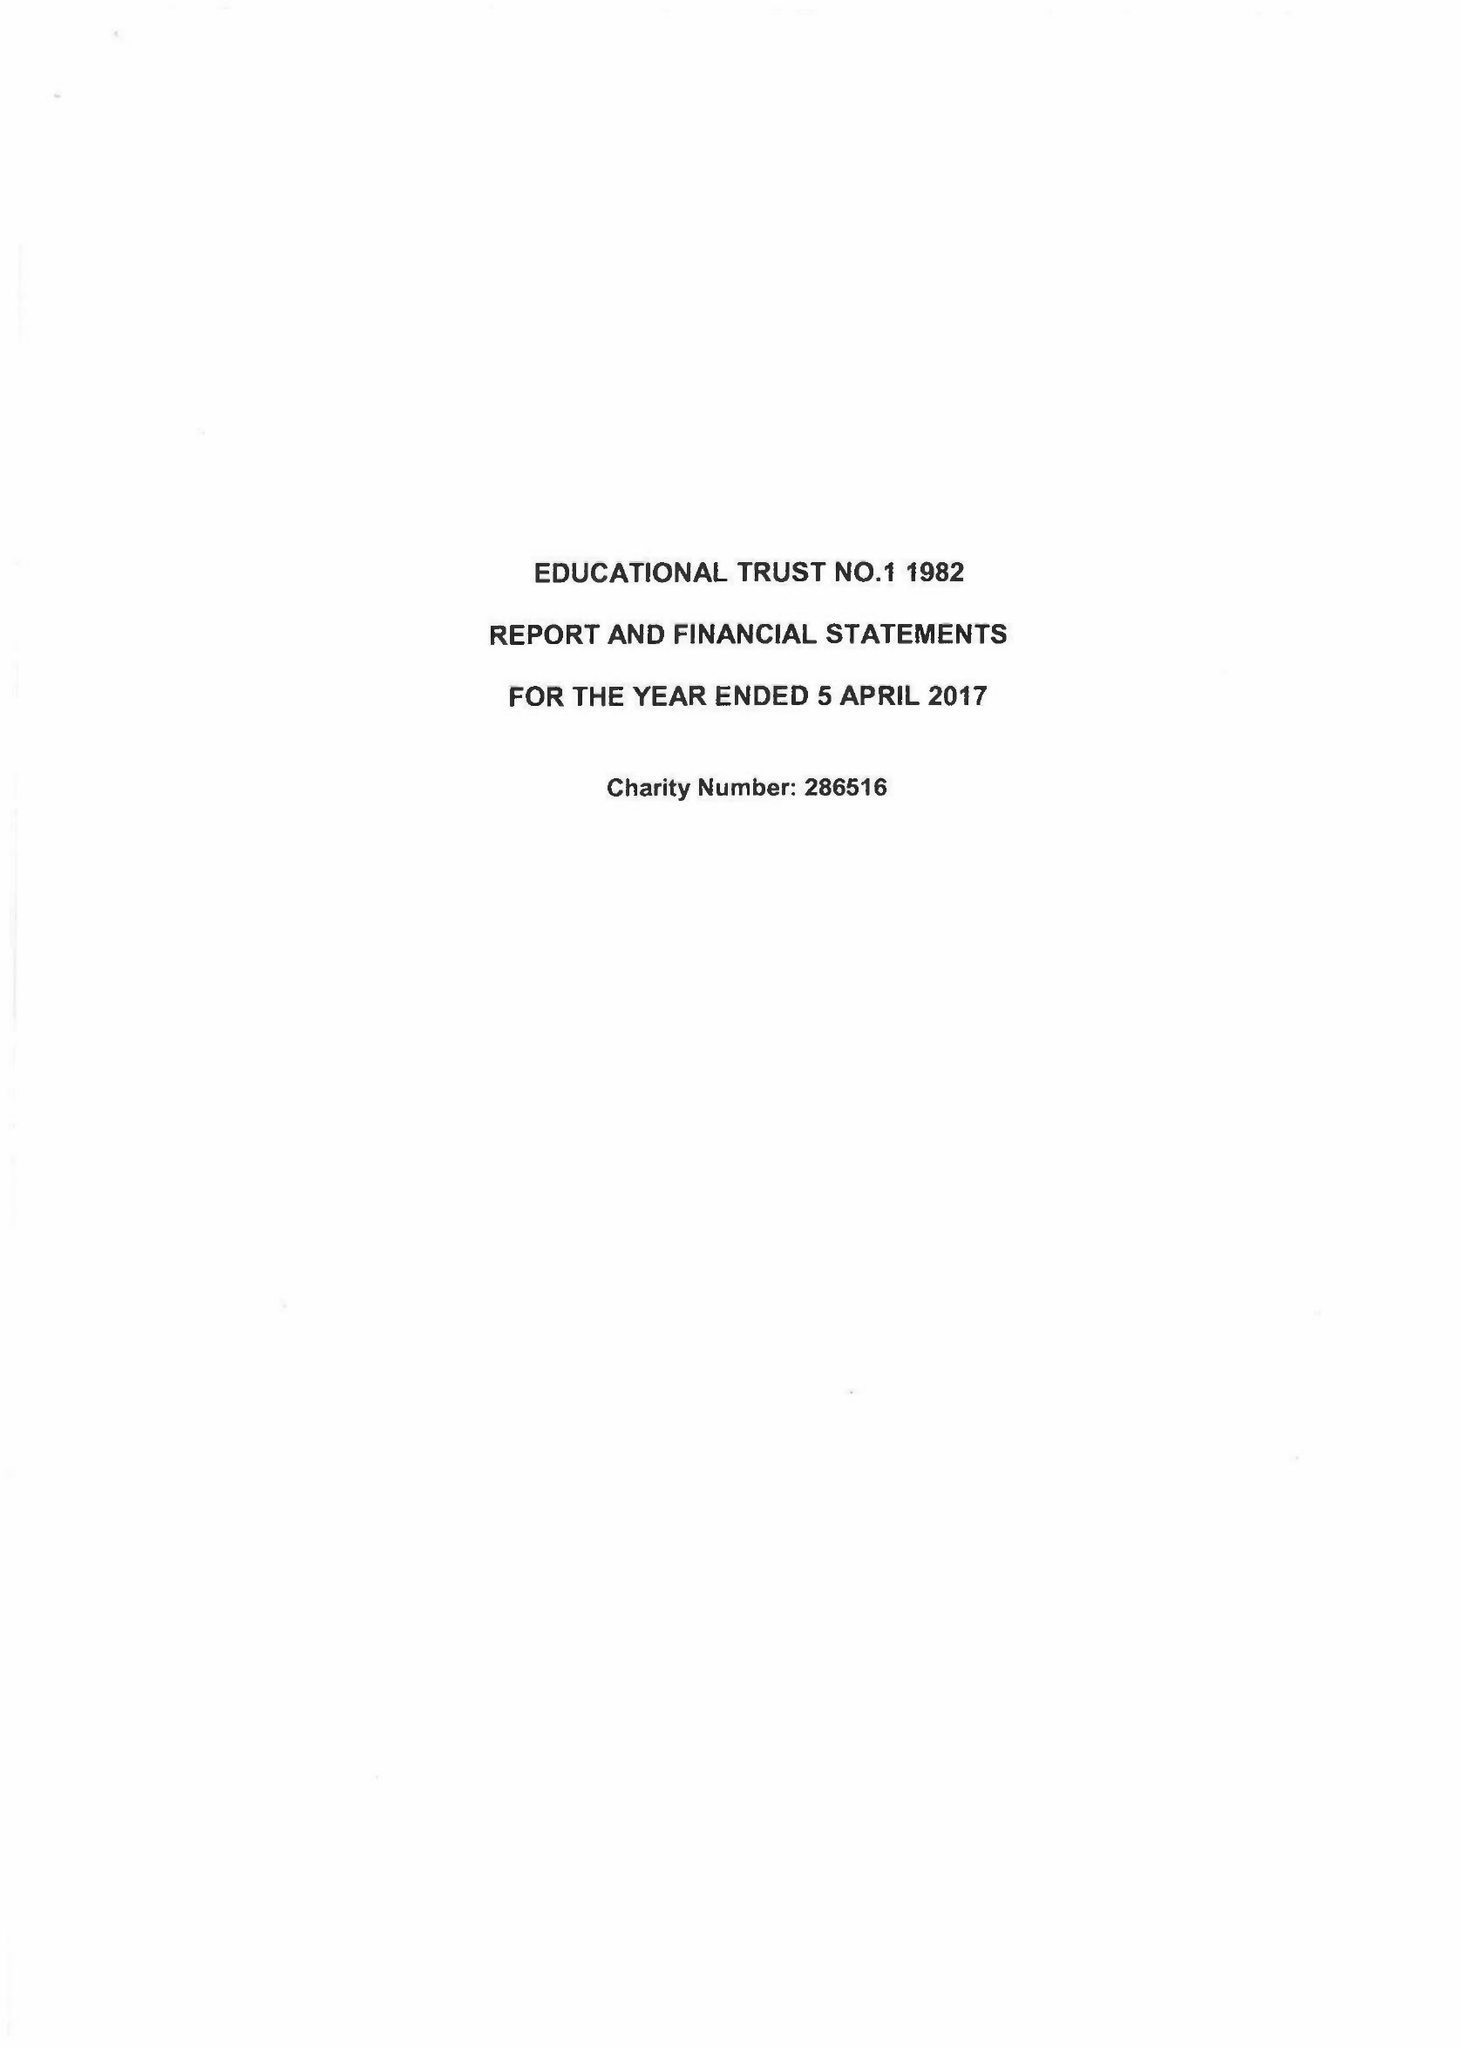What is the value for the address__street_line?
Answer the question using a single word or phrase. THE FORUM PARKWAY 